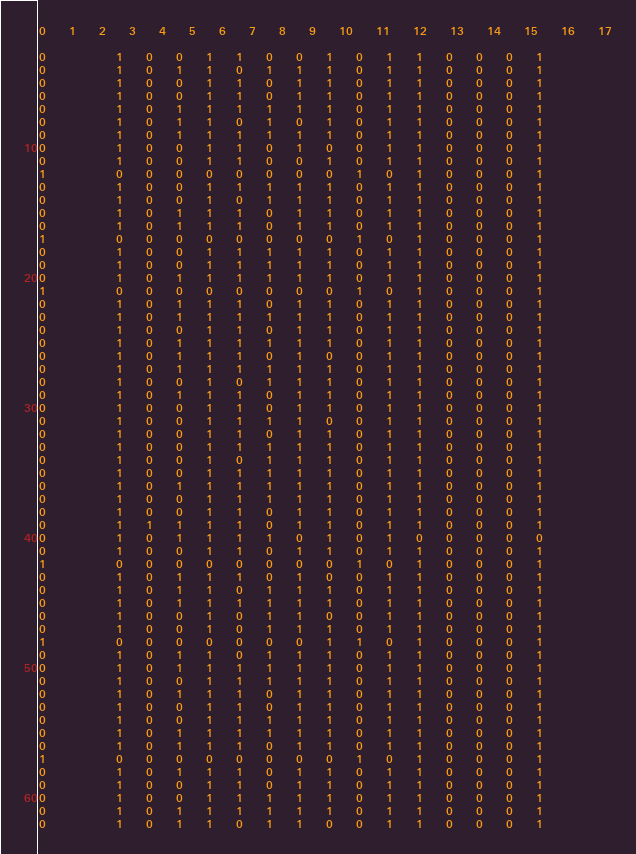<code> <loc_0><loc_0><loc_500><loc_500><_SQL_>0	1	2	3	4	5	6	7	8	9	10	11	12	13	14	15	16	17

0			1	0	0	1	1	0	0	1	0	1	1	0	0	0	1	
0			1	0	1	1	0	1	1	1	0	1	1	0	0	0	1	
0			1	0	0	1	1	0	1	1	0	1	1	0	0	0	1	
0			1	0	0	1	1	0	1	1	0	1	1	0	0	0	1	
0			1	0	1	1	1	1	1	1	0	1	1	0	0	0	1	
0			1	0	1	1	0	1	0	1	0	1	1	0	0	0	1	
0			1	0	1	1	1	1	1	1	0	1	1	0	0	0	1	
0			1	0	0	1	1	0	1	0	0	1	1	0	0	0	1	
0			1	0	0	1	1	0	0	1	0	1	1	0	0	0	1	
1			0	0	0	0	0	0	0	0	1	0	1	0	0	0	1	
0			1	0	0	1	1	1	1	1	0	1	1	0	0	0	1	
0			1	0	0	1	0	1	1	1	0	1	1	0	0	0	1	
0			1	0	1	1	1	0	1	1	0	1	1	0	0	0	1	
0			1	0	1	1	1	0	1	1	0	1	1	0	0	0	1	
1			0	0	0	0	0	0	0	0	1	0	1	0	0	0	1	
0			1	0	0	1	1	1	1	1	0	1	1	0	0	0	1	
0			1	0	0	1	1	1	1	1	0	1	1	0	0	0	1	
0			1	0	1	1	1	1	1	1	0	1	1	0	0	0	1	
1			0	0	0	0	0	0	0	0	1	0	1	0	0	0	1	
0			1	0	1	1	1	0	1	1	0	1	1	0	0	0	1	
0			1	0	1	1	1	1	1	1	0	1	1	0	0	0	1	
0			1	0	0	1	1	0	1	1	0	1	1	0	0	0	1	
0			1	0	1	1	1	1	1	1	0	1	1	0	0	0	1	
0			1	0	1	1	1	0	1	0	0	1	1	0	0	0	1	
0			1	0	1	1	1	1	1	1	0	1	1	0	0	0	1	
0			1	0	0	1	0	1	1	1	0	1	1	0	0	0	1	
0			1	0	1	1	1	0	1	1	0	1	1	0	0	0	1	
0			1	0	0	1	1	0	1	1	0	1	1	0	0	0	1	
0			1	0	0	1	1	1	1	0	0	1	1	0	0	0	1	
0			1	0	0	1	1	0	1	1	0	1	1	0	0	0	1	
0			1	0	0	1	1	1	1	1	0	1	1	0	0	0	1	
0			1	0	0	1	0	1	1	1	0	1	1	0	0	0	1	
0			1	0	0	1	1	1	1	1	0	1	1	0	0	0	1	
0			1	0	1	1	1	1	1	1	0	1	1	0	0	0	1	
0			1	0	0	1	1	1	1	1	0	1	1	0	0	0	1	
0			1	0	0	1	1	0	1	1	0	1	1	0	0	0	1	
0			1	1	1	1	1	0	1	1	0	1	1	0	0	0	1	
0			1	0	1	1	1	1	0	1	0	1	0	0	0	0	0	
0			1	0	0	1	1	0	1	1	0	1	1	0	0	0	1	
1			0	0	0	0	0	0	0	0	1	0	1	0	0	0	1	
0			1	0	1	1	1	0	1	0	0	1	1	0	0	0	1	
0			1	0	1	1	0	1	1	1	0	1	1	0	0	0	1	
0			1	0	1	1	1	1	1	1	0	1	1	0	0	0	1	
0			1	0	0	1	0	1	1	0	0	1	1	0	0	0	1	
0			1	0	0	1	0	1	1	1	0	1	1	0	0	0	1	
1			0	0	0	0	0	0	0	1	1	0	1	0	0	0	1	
0			1	0	1	1	0	1	1	1	0	1	1	0	0	0	1	
0			1	0	1	1	1	1	1	1	0	1	1	0	0	0	1	
0			1	0	0	1	1	1	1	1	0	1	1	0	0	0	1	
0			1	0	1	1	1	0	1	1	0	1	1	0	0	0	1	
0			1	0	0	1	1	0	1	1	0	1	1	0	0	0	1	
0			1	0	0	1	1	1	1	1	0	1	1	0	0	0	1	
0			1	0	1	1	1	1	1	1	0	1	1	0	0	0	1	
0			1	0	1	1	1	0	1	1	0	1	1	0	0	0	1	
1			0	0	0	0	0	0	0	0	1	0	1	0	0	0	1	
0			1	0	1	1	1	0	1	1	0	1	1	0	0	0	1	
0			1	0	0	1	1	0	1	1	0	1	1	0	0	0	1	
0			1	0	0	1	1	1	1	1	0	1	1	0	0	0	1	
0			1	0	1	1	1	1	1	1	0	1	1	0	0	0	1	
0			1	0	1	1	0	1	1	0	0	1	1	0	0	0	1	</code> 